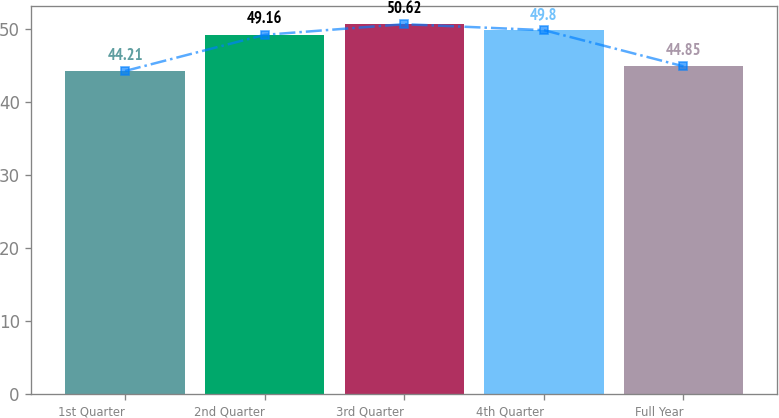Convert chart to OTSL. <chart><loc_0><loc_0><loc_500><loc_500><bar_chart><fcel>1st Quarter<fcel>2nd Quarter<fcel>3rd Quarter<fcel>4th Quarter<fcel>Full Year<nl><fcel>44.21<fcel>49.16<fcel>50.62<fcel>49.8<fcel>44.85<nl></chart> 